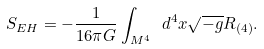Convert formula to latex. <formula><loc_0><loc_0><loc_500><loc_500>S _ { E H } = - \frac { 1 } { 1 6 \pi G } \int _ { M ^ { 4 } } \ d ^ { 4 } x \sqrt { - g } R _ { ( 4 ) } .</formula> 